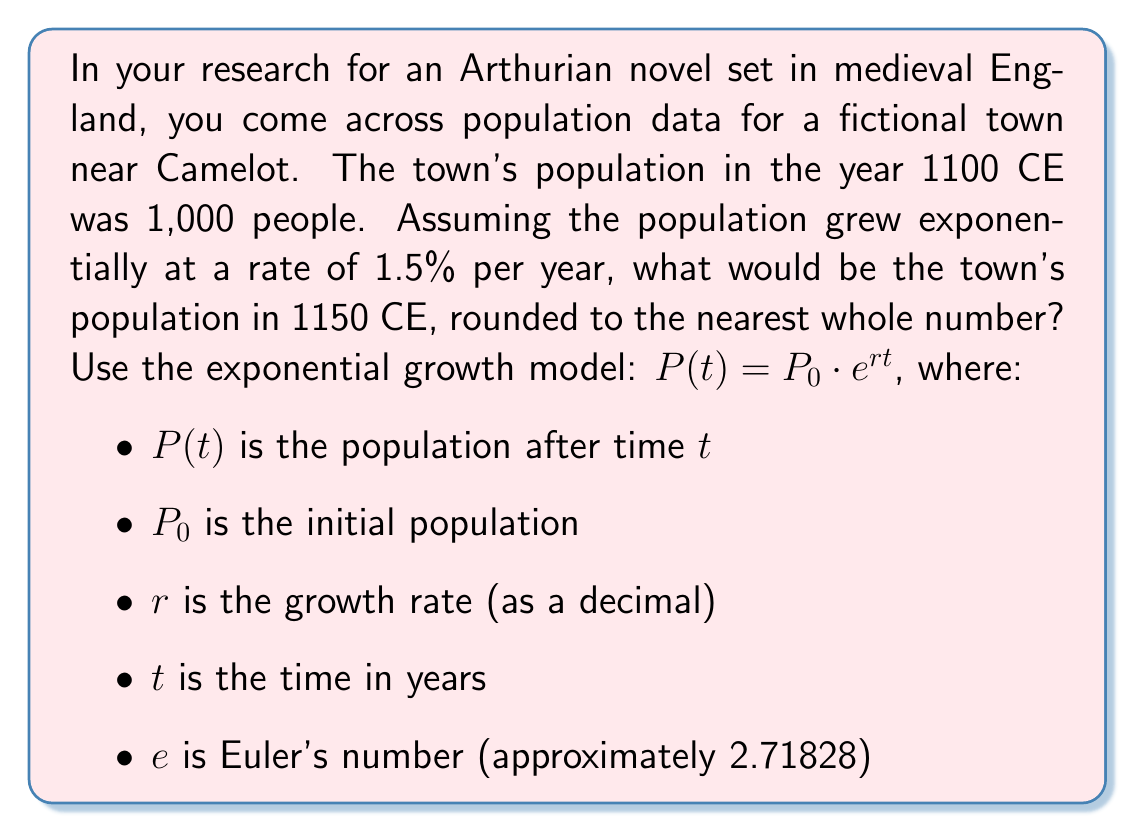Can you solve this math problem? To solve this problem, we'll use the exponential growth model:

$P(t) = P_0 \cdot e^{rt}$

Given:
$P_0 = 1,000$ (initial population in 1100 CE)
$r = 0.015$ (1.5% growth rate expressed as a decimal)
$t = 50$ (years between 1100 CE and 1150 CE)

Let's substitute these values into the equation:

$P(50) = 1,000 \cdot e^{0.015 \cdot 50}$

Now, let's calculate step by step:

1. Simplify the exponent: $0.015 \cdot 50 = 0.75$

2. Our equation becomes: $P(50) = 1,000 \cdot e^{0.75}$

3. Calculate $e^{0.75}$:
   $e^{0.75} \approx 2.117000016$

4. Multiply: $1,000 \cdot 2.117000016 = 2,117.000016$

5. Round to the nearest whole number: 2,117

Therefore, the population of the town near Camelot in 1150 CE would be approximately 2,117 people.
Answer: 2,117 people 